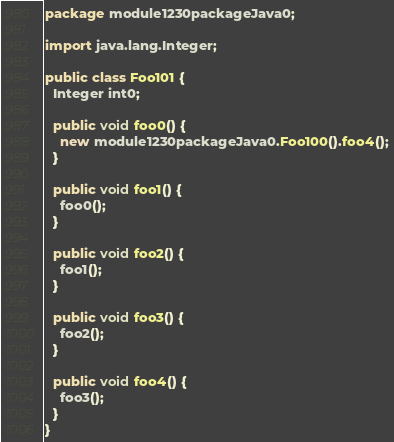Convert code to text. <code><loc_0><loc_0><loc_500><loc_500><_Java_>package module1230packageJava0;

import java.lang.Integer;

public class Foo101 {
  Integer int0;

  public void foo0() {
    new module1230packageJava0.Foo100().foo4();
  }

  public void foo1() {
    foo0();
  }

  public void foo2() {
    foo1();
  }

  public void foo3() {
    foo2();
  }

  public void foo4() {
    foo3();
  }
}
</code> 